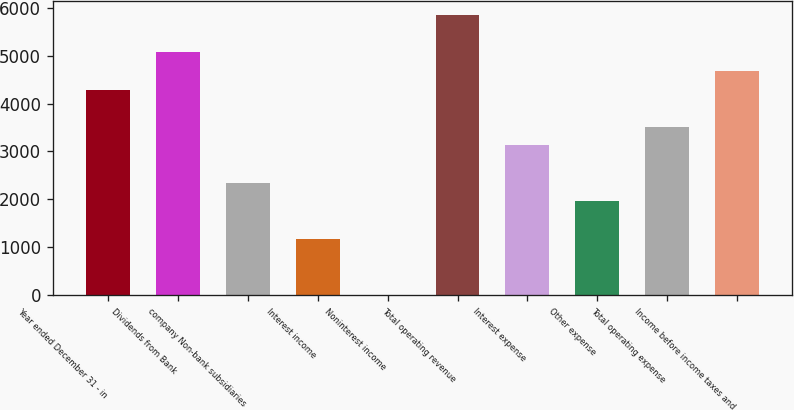<chart> <loc_0><loc_0><loc_500><loc_500><bar_chart><fcel>Year ended December 31 - in<fcel>Dividends from Bank<fcel>company Non-bank subsidiaries<fcel>Interest income<fcel>Noninterest income<fcel>Total operating revenue<fcel>Interest expense<fcel>Other expense<fcel>Total operating expense<fcel>Income before income taxes and<nl><fcel>4292<fcel>5070<fcel>2347<fcel>1180<fcel>13<fcel>5848<fcel>3125<fcel>1958<fcel>3514<fcel>4681<nl></chart> 